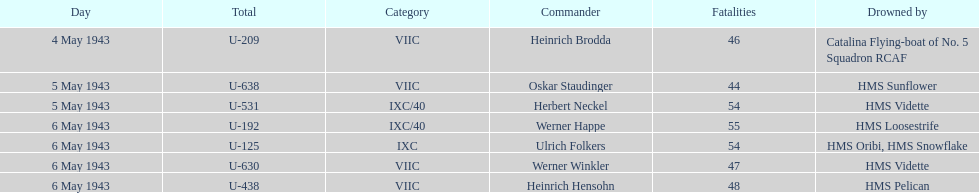What was the only captain sunk by hms pelican? Heinrich Hensohn. 